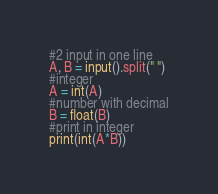<code> <loc_0><loc_0><loc_500><loc_500><_Python_>#2 input in one line
A, B = input().split(" ")
#integer
A = int(A)
#number with decimal
B = float(B)
#print in integer
print(int(A*B))
</code> 